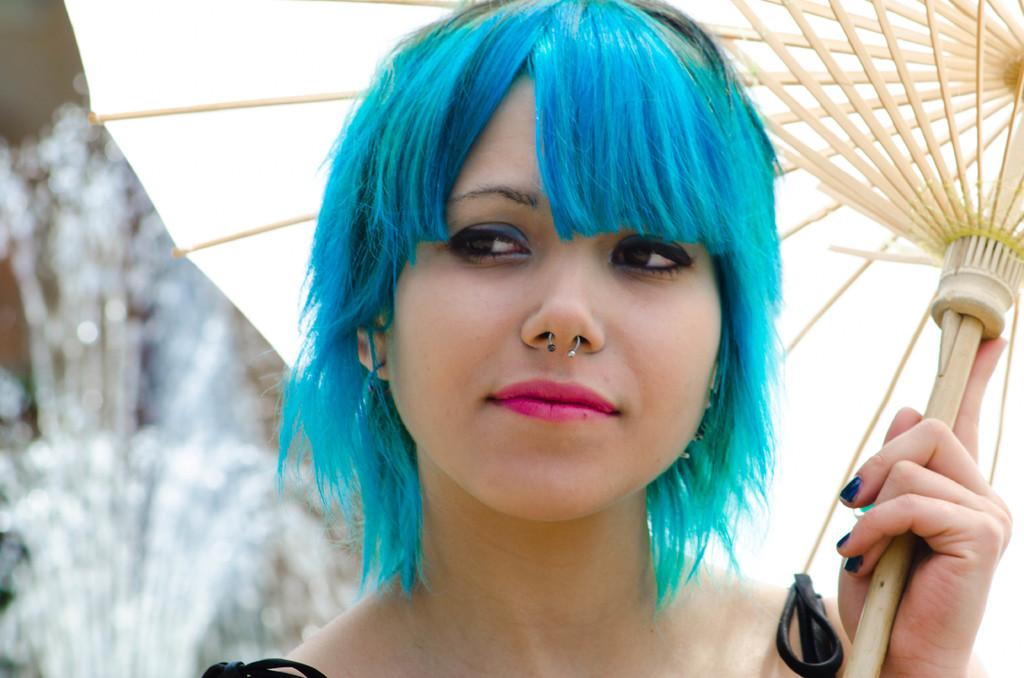What can be seen in the image? There is a person in the image. Can you describe the person's appearance? The person has blue hair. What is the person holding in the image? The person is holding an umbrella. How would you describe the background of the image? The background of the image is blurred. What type of stamp can be seen on the person's forehead in the image? There is no stamp visible on the person's forehead in the image. Can you tell me how many dogs are present in the image? There are no dogs present in the image; it features a person holding an umbrella. 